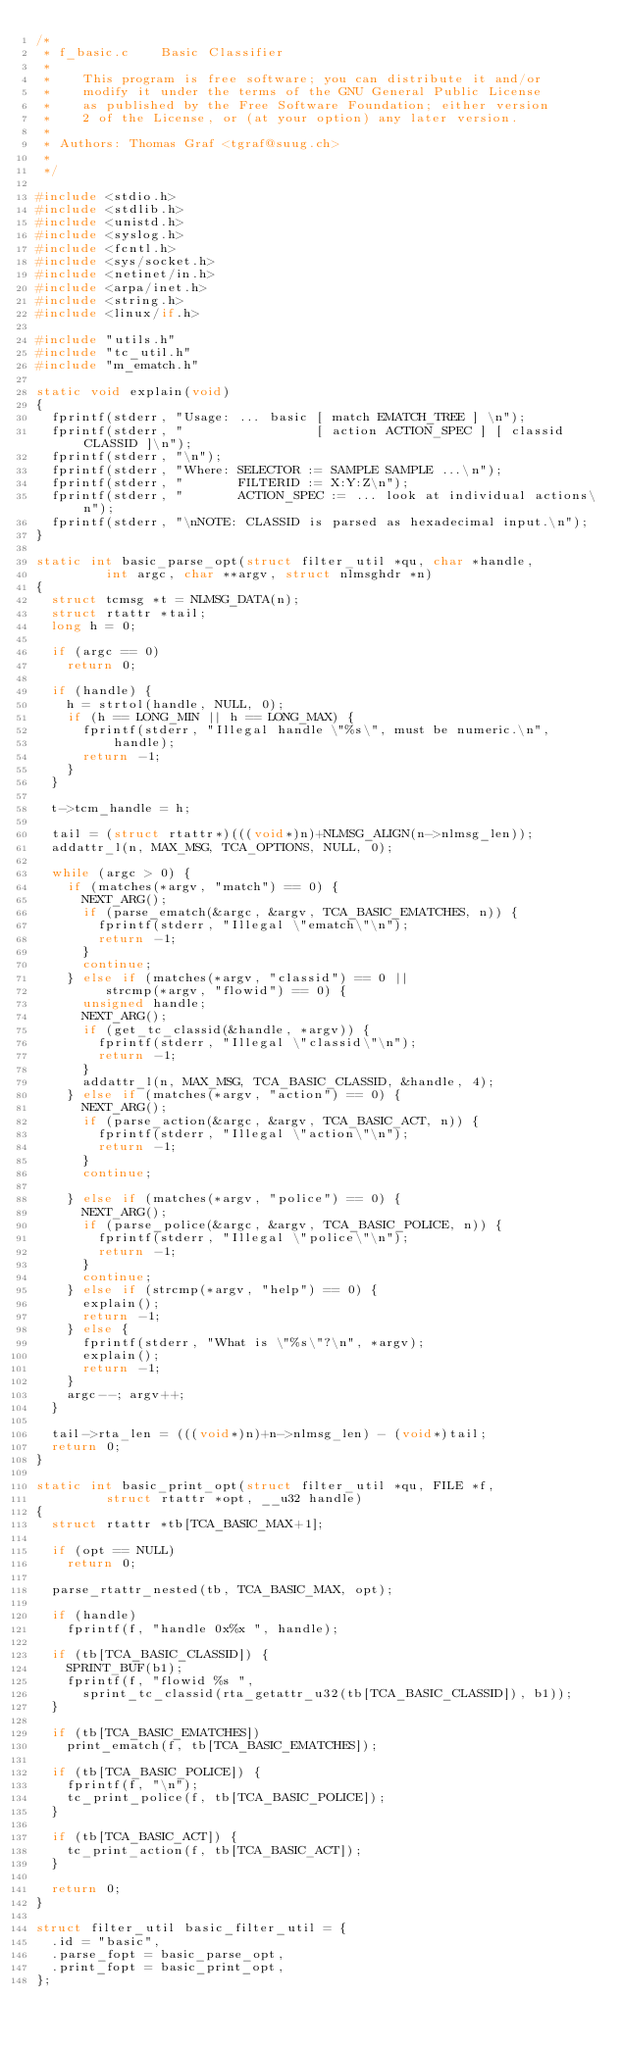<code> <loc_0><loc_0><loc_500><loc_500><_C_>/*
 * f_basic.c		Basic Classifier
 *
 *		This program is free software; you can distribute it and/or
 *		modify it under the terms of the GNU General Public License
 *		as published by the Free Software Foundation; either version
 *		2 of the License, or (at your option) any later version.
 *
 * Authors:	Thomas Graf <tgraf@suug.ch>
 *
 */

#include <stdio.h>
#include <stdlib.h>
#include <unistd.h>
#include <syslog.h>
#include <fcntl.h>
#include <sys/socket.h>
#include <netinet/in.h>
#include <arpa/inet.h>
#include <string.h>
#include <linux/if.h>

#include "utils.h"
#include "tc_util.h"
#include "m_ematch.h"

static void explain(void)
{
	fprintf(stderr, "Usage: ... basic [ match EMATCH_TREE ] \n");
	fprintf(stderr, "                 [ action ACTION_SPEC ] [ classid CLASSID ]\n");
	fprintf(stderr, "\n");
	fprintf(stderr, "Where: SELECTOR := SAMPLE SAMPLE ...\n");
	fprintf(stderr, "       FILTERID := X:Y:Z\n");
	fprintf(stderr, "       ACTION_SPEC := ... look at individual actions\n");
	fprintf(stderr, "\nNOTE: CLASSID is parsed as hexadecimal input.\n");
}

static int basic_parse_opt(struct filter_util *qu, char *handle,
			   int argc, char **argv, struct nlmsghdr *n)
{
	struct tcmsg *t = NLMSG_DATA(n);
	struct rtattr *tail;
	long h = 0;

	if (argc == 0)
		return 0;

	if (handle) {
		h = strtol(handle, NULL, 0);
		if (h == LONG_MIN || h == LONG_MAX) {
			fprintf(stderr, "Illegal handle \"%s\", must be numeric.\n",
			    handle);
			return -1;
		}
	}

	t->tcm_handle = h;

	tail = (struct rtattr*)(((void*)n)+NLMSG_ALIGN(n->nlmsg_len));
	addattr_l(n, MAX_MSG, TCA_OPTIONS, NULL, 0);

	while (argc > 0) {
		if (matches(*argv, "match") == 0) {
			NEXT_ARG();
			if (parse_ematch(&argc, &argv, TCA_BASIC_EMATCHES, n)) {
				fprintf(stderr, "Illegal \"ematch\"\n");
				return -1;
			}
			continue;
		} else if (matches(*argv, "classid") == 0 ||
			   strcmp(*argv, "flowid") == 0) {
			unsigned handle;
			NEXT_ARG();
			if (get_tc_classid(&handle, *argv)) {
				fprintf(stderr, "Illegal \"classid\"\n");
				return -1;
			}
			addattr_l(n, MAX_MSG, TCA_BASIC_CLASSID, &handle, 4);
		} else if (matches(*argv, "action") == 0) {
			NEXT_ARG();
			if (parse_action(&argc, &argv, TCA_BASIC_ACT, n)) {
				fprintf(stderr, "Illegal \"action\"\n");
				return -1;
			}
			continue;

		} else if (matches(*argv, "police") == 0) {
			NEXT_ARG();
			if (parse_police(&argc, &argv, TCA_BASIC_POLICE, n)) {
				fprintf(stderr, "Illegal \"police\"\n");
				return -1;
			}
			continue;
		} else if (strcmp(*argv, "help") == 0) {
			explain();
			return -1;
		} else {
			fprintf(stderr, "What is \"%s\"?\n", *argv);
			explain();
			return -1;
		}
		argc--; argv++;
	}

	tail->rta_len = (((void*)n)+n->nlmsg_len) - (void*)tail;
	return 0;
}

static int basic_print_opt(struct filter_util *qu, FILE *f,
			   struct rtattr *opt, __u32 handle)
{
	struct rtattr *tb[TCA_BASIC_MAX+1];

	if (opt == NULL)
		return 0;

	parse_rtattr_nested(tb, TCA_BASIC_MAX, opt);

	if (handle)
		fprintf(f, "handle 0x%x ", handle);

	if (tb[TCA_BASIC_CLASSID]) {
		SPRINT_BUF(b1);
		fprintf(f, "flowid %s ",
			sprint_tc_classid(rta_getattr_u32(tb[TCA_BASIC_CLASSID]), b1));
	}

	if (tb[TCA_BASIC_EMATCHES])
		print_ematch(f, tb[TCA_BASIC_EMATCHES]);

	if (tb[TCA_BASIC_POLICE]) {
		fprintf(f, "\n");
		tc_print_police(f, tb[TCA_BASIC_POLICE]);
	}

	if (tb[TCA_BASIC_ACT]) {
		tc_print_action(f, tb[TCA_BASIC_ACT]);
	}

	return 0;
}

struct filter_util basic_filter_util = {
	.id = "basic",
	.parse_fopt = basic_parse_opt,
	.print_fopt = basic_print_opt,
};
</code> 